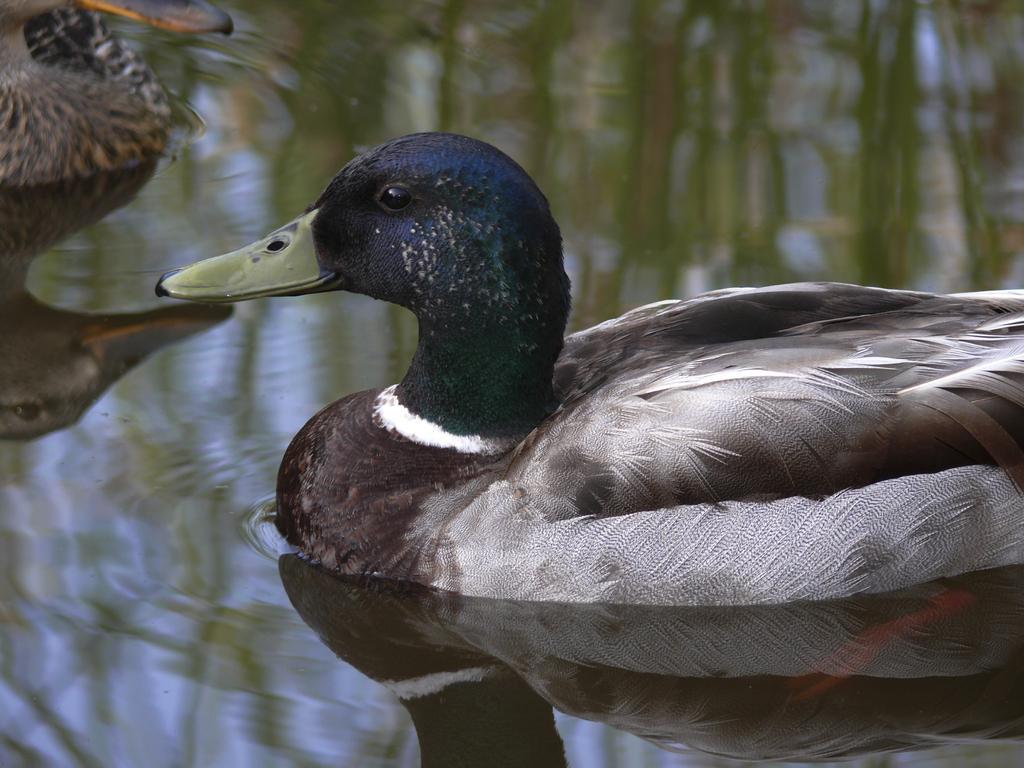Please provide a concise description of this image. This picture is clicked outside. In the center we can see the two birds seems to be the ducks in the water body and we can see the reflections of some objects on the water body. 